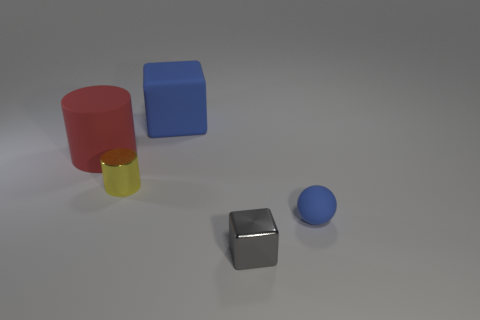Is the number of rubber cubes greater than the number of cylinders?
Make the answer very short. No. How many objects are in front of the small shiny cylinder and behind the tiny gray cube?
Provide a succinct answer. 1. How many objects are in front of the large object on the left side of the yellow cylinder?
Give a very brief answer. 3. Do the cube behind the red matte cylinder and the object that is left of the small yellow object have the same size?
Offer a very short reply. Yes. How many large matte cylinders are there?
Offer a very short reply. 1. What number of blue things are the same material as the tiny gray thing?
Offer a terse response. 0. Are there the same number of cylinders that are behind the yellow shiny cylinder and large purple shiny objects?
Your answer should be compact. No. What is the material of the block that is the same color as the tiny rubber object?
Offer a terse response. Rubber. Does the shiny cylinder have the same size as the cube behind the red matte object?
Your response must be concise. No. What number of other objects are the same size as the gray thing?
Offer a very short reply. 2. 